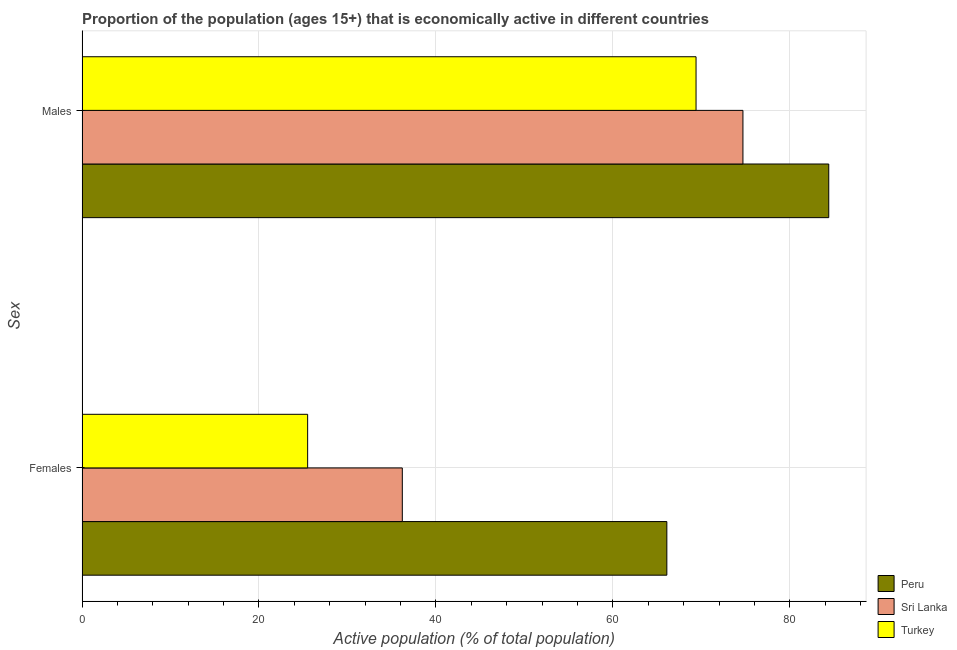How many bars are there on the 2nd tick from the top?
Offer a very short reply. 3. How many bars are there on the 2nd tick from the bottom?
Provide a succinct answer. 3. What is the label of the 1st group of bars from the top?
Keep it short and to the point. Males. What is the percentage of economically active male population in Turkey?
Provide a short and direct response. 69.4. Across all countries, what is the maximum percentage of economically active female population?
Your answer should be very brief. 66.1. Across all countries, what is the minimum percentage of economically active male population?
Make the answer very short. 69.4. What is the total percentage of economically active female population in the graph?
Your answer should be very brief. 127.8. What is the difference between the percentage of economically active male population in Peru and that in Turkey?
Keep it short and to the point. 15. What is the difference between the percentage of economically active female population in Peru and the percentage of economically active male population in Turkey?
Provide a short and direct response. -3.3. What is the average percentage of economically active female population per country?
Ensure brevity in your answer.  42.6. What is the difference between the percentage of economically active female population and percentage of economically active male population in Peru?
Provide a short and direct response. -18.3. What is the ratio of the percentage of economically active male population in Sri Lanka to that in Peru?
Your answer should be compact. 0.89. What does the 3rd bar from the top in Females represents?
Ensure brevity in your answer.  Peru. What does the 2nd bar from the bottom in Females represents?
Give a very brief answer. Sri Lanka. Are all the bars in the graph horizontal?
Your answer should be compact. Yes. How many countries are there in the graph?
Provide a succinct answer. 3. What is the difference between two consecutive major ticks on the X-axis?
Your answer should be compact. 20. Does the graph contain any zero values?
Your response must be concise. No. Does the graph contain grids?
Give a very brief answer. Yes. Where does the legend appear in the graph?
Make the answer very short. Bottom right. How many legend labels are there?
Ensure brevity in your answer.  3. What is the title of the graph?
Give a very brief answer. Proportion of the population (ages 15+) that is economically active in different countries. Does "Benin" appear as one of the legend labels in the graph?
Provide a short and direct response. No. What is the label or title of the X-axis?
Provide a short and direct response. Active population (% of total population). What is the label or title of the Y-axis?
Offer a very short reply. Sex. What is the Active population (% of total population) in Peru in Females?
Keep it short and to the point. 66.1. What is the Active population (% of total population) in Sri Lanka in Females?
Your response must be concise. 36.2. What is the Active population (% of total population) of Peru in Males?
Make the answer very short. 84.4. What is the Active population (% of total population) in Sri Lanka in Males?
Provide a succinct answer. 74.7. What is the Active population (% of total population) of Turkey in Males?
Keep it short and to the point. 69.4. Across all Sex, what is the maximum Active population (% of total population) of Peru?
Offer a very short reply. 84.4. Across all Sex, what is the maximum Active population (% of total population) of Sri Lanka?
Provide a short and direct response. 74.7. Across all Sex, what is the maximum Active population (% of total population) in Turkey?
Your answer should be very brief. 69.4. Across all Sex, what is the minimum Active population (% of total population) of Peru?
Your answer should be compact. 66.1. Across all Sex, what is the minimum Active population (% of total population) in Sri Lanka?
Ensure brevity in your answer.  36.2. What is the total Active population (% of total population) in Peru in the graph?
Provide a short and direct response. 150.5. What is the total Active population (% of total population) in Sri Lanka in the graph?
Keep it short and to the point. 110.9. What is the total Active population (% of total population) in Turkey in the graph?
Your answer should be very brief. 94.9. What is the difference between the Active population (% of total population) in Peru in Females and that in Males?
Give a very brief answer. -18.3. What is the difference between the Active population (% of total population) of Sri Lanka in Females and that in Males?
Make the answer very short. -38.5. What is the difference between the Active population (% of total population) of Turkey in Females and that in Males?
Your answer should be very brief. -43.9. What is the difference between the Active population (% of total population) in Sri Lanka in Females and the Active population (% of total population) in Turkey in Males?
Make the answer very short. -33.2. What is the average Active population (% of total population) in Peru per Sex?
Provide a short and direct response. 75.25. What is the average Active population (% of total population) in Sri Lanka per Sex?
Your response must be concise. 55.45. What is the average Active population (% of total population) in Turkey per Sex?
Your answer should be compact. 47.45. What is the difference between the Active population (% of total population) of Peru and Active population (% of total population) of Sri Lanka in Females?
Provide a short and direct response. 29.9. What is the difference between the Active population (% of total population) in Peru and Active population (% of total population) in Turkey in Females?
Keep it short and to the point. 40.6. What is the difference between the Active population (% of total population) in Sri Lanka and Active population (% of total population) in Turkey in Females?
Offer a terse response. 10.7. What is the difference between the Active population (% of total population) of Peru and Active population (% of total population) of Turkey in Males?
Make the answer very short. 15. What is the ratio of the Active population (% of total population) of Peru in Females to that in Males?
Your answer should be very brief. 0.78. What is the ratio of the Active population (% of total population) of Sri Lanka in Females to that in Males?
Make the answer very short. 0.48. What is the ratio of the Active population (% of total population) of Turkey in Females to that in Males?
Make the answer very short. 0.37. What is the difference between the highest and the second highest Active population (% of total population) of Peru?
Keep it short and to the point. 18.3. What is the difference between the highest and the second highest Active population (% of total population) of Sri Lanka?
Your response must be concise. 38.5. What is the difference between the highest and the second highest Active population (% of total population) in Turkey?
Offer a very short reply. 43.9. What is the difference between the highest and the lowest Active population (% of total population) in Peru?
Provide a succinct answer. 18.3. What is the difference between the highest and the lowest Active population (% of total population) of Sri Lanka?
Keep it short and to the point. 38.5. What is the difference between the highest and the lowest Active population (% of total population) in Turkey?
Ensure brevity in your answer.  43.9. 